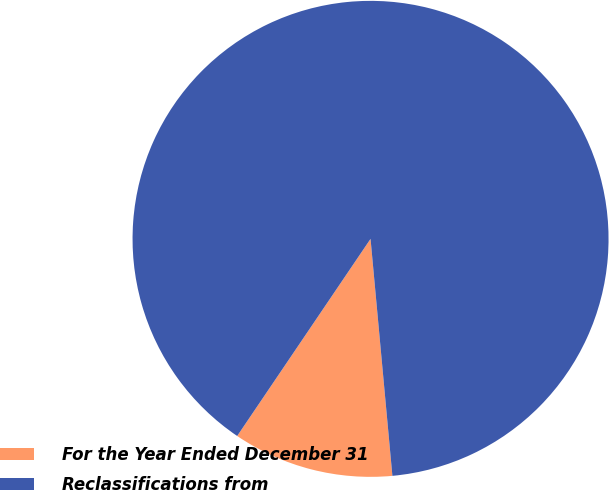Convert chart to OTSL. <chart><loc_0><loc_0><loc_500><loc_500><pie_chart><fcel>For the Year Ended December 31<fcel>Reclassifications from<nl><fcel>10.93%<fcel>89.07%<nl></chart> 